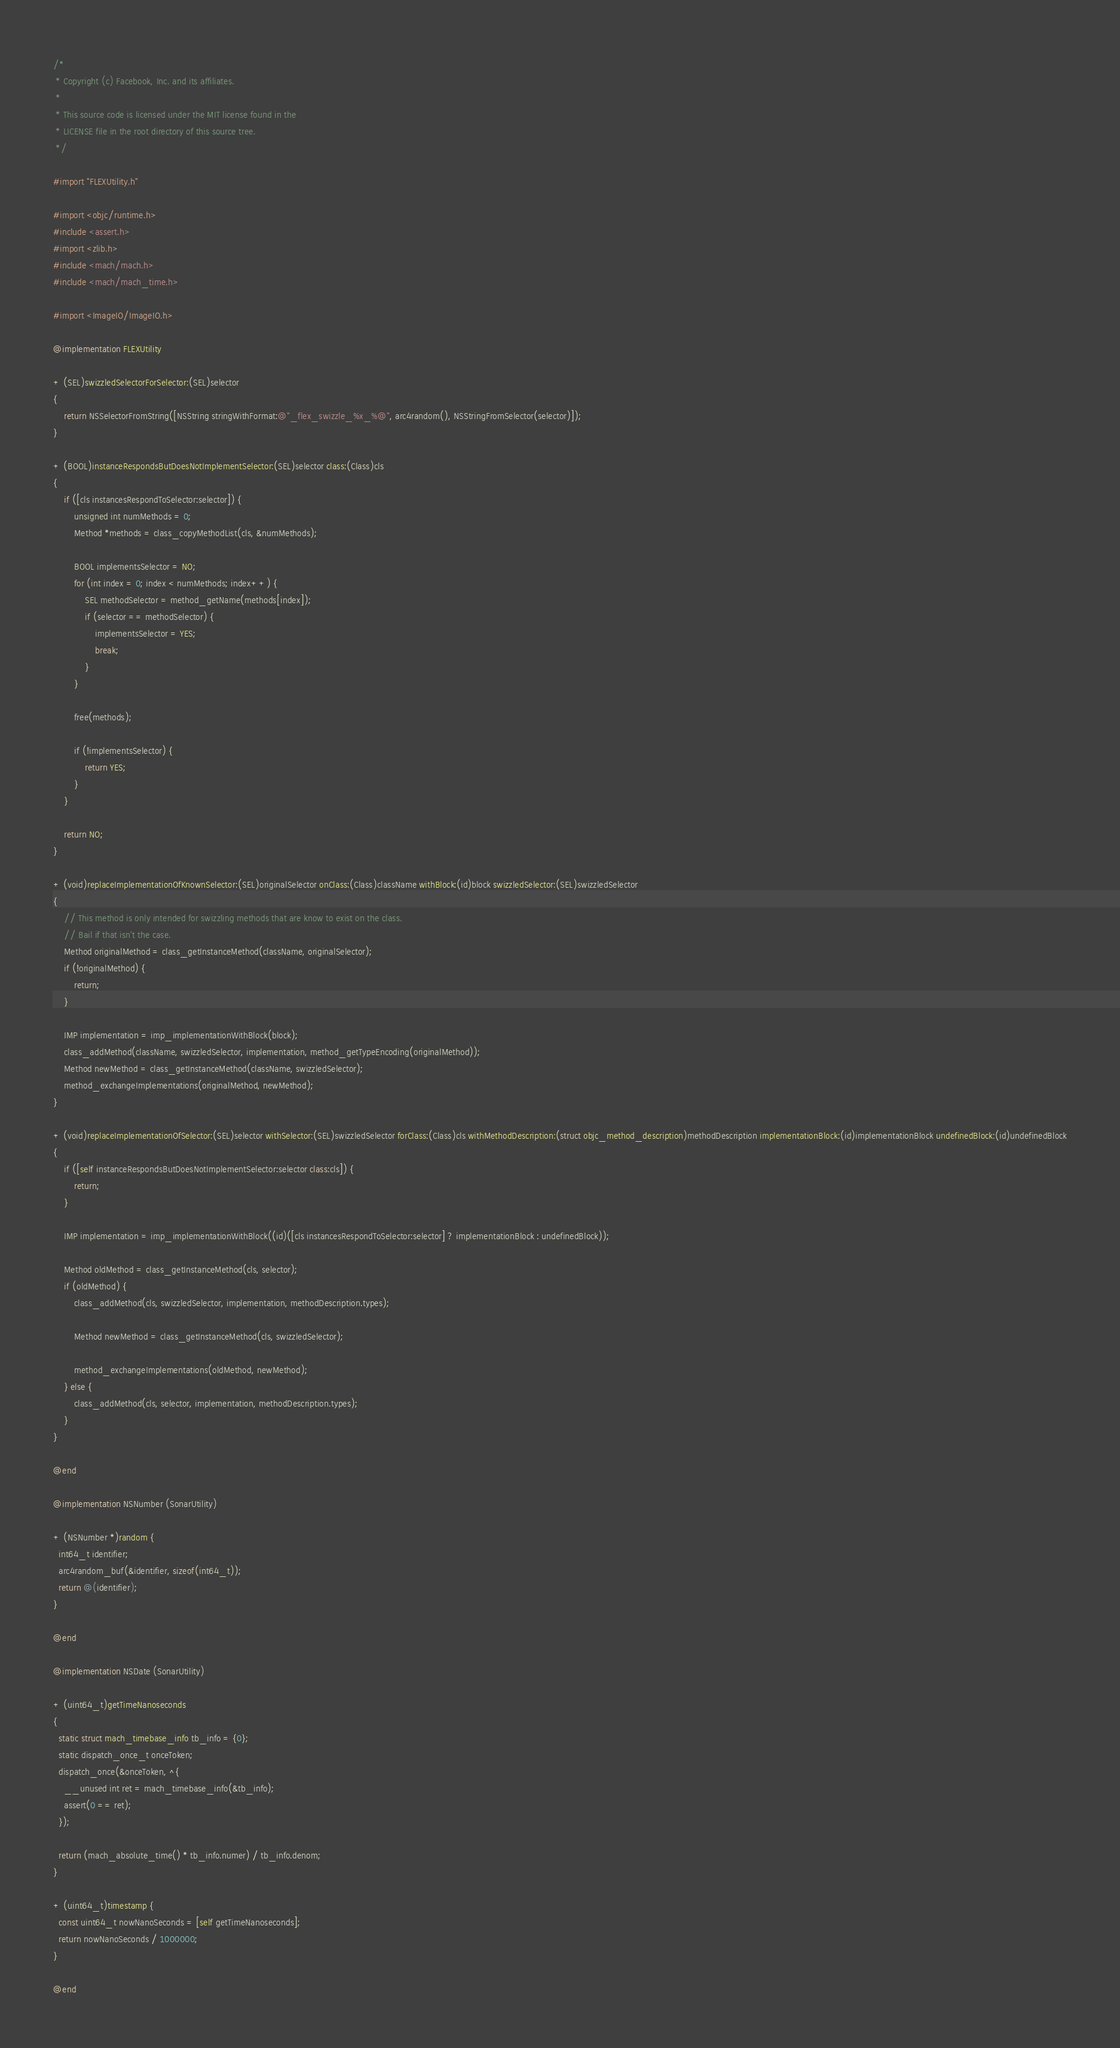Convert code to text. <code><loc_0><loc_0><loc_500><loc_500><_ObjectiveC_>/*
 * Copyright (c) Facebook, Inc. and its affiliates.
 *
 * This source code is licensed under the MIT license found in the
 * LICENSE file in the root directory of this source tree.
 */

#import "FLEXUtility.h"

#import <objc/runtime.h>
#include <assert.h>
#import <zlib.h>
#include <mach/mach.h>
#include <mach/mach_time.h>

#import <ImageIO/ImageIO.h>

@implementation FLEXUtility

+ (SEL)swizzledSelectorForSelector:(SEL)selector
{
    return NSSelectorFromString([NSString stringWithFormat:@"_flex_swizzle_%x_%@", arc4random(), NSStringFromSelector(selector)]);
}

+ (BOOL)instanceRespondsButDoesNotImplementSelector:(SEL)selector class:(Class)cls
{
    if ([cls instancesRespondToSelector:selector]) {
        unsigned int numMethods = 0;
        Method *methods = class_copyMethodList(cls, &numMethods);

        BOOL implementsSelector = NO;
        for (int index = 0; index < numMethods; index++) {
            SEL methodSelector = method_getName(methods[index]);
            if (selector == methodSelector) {
                implementsSelector = YES;
                break;
            }
        }

        free(methods);

        if (!implementsSelector) {
            return YES;
        }
    }

    return NO;
}

+ (void)replaceImplementationOfKnownSelector:(SEL)originalSelector onClass:(Class)className withBlock:(id)block swizzledSelector:(SEL)swizzledSelector
{
    // This method is only intended for swizzling methods that are know to exist on the class.
    // Bail if that isn't the case.
    Method originalMethod = class_getInstanceMethod(className, originalSelector);
    if (!originalMethod) {
        return;
    }

    IMP implementation = imp_implementationWithBlock(block);
    class_addMethod(className, swizzledSelector, implementation, method_getTypeEncoding(originalMethod));
    Method newMethod = class_getInstanceMethod(className, swizzledSelector);
    method_exchangeImplementations(originalMethod, newMethod);
}

+ (void)replaceImplementationOfSelector:(SEL)selector withSelector:(SEL)swizzledSelector forClass:(Class)cls withMethodDescription:(struct objc_method_description)methodDescription implementationBlock:(id)implementationBlock undefinedBlock:(id)undefinedBlock
{
    if ([self instanceRespondsButDoesNotImplementSelector:selector class:cls]) {
        return;
    }

    IMP implementation = imp_implementationWithBlock((id)([cls instancesRespondToSelector:selector] ? implementationBlock : undefinedBlock));

    Method oldMethod = class_getInstanceMethod(cls, selector);
    if (oldMethod) {
        class_addMethod(cls, swizzledSelector, implementation, methodDescription.types);

        Method newMethod = class_getInstanceMethod(cls, swizzledSelector);

        method_exchangeImplementations(oldMethod, newMethod);
    } else {
        class_addMethod(cls, selector, implementation, methodDescription.types);
    }
}

@end

@implementation NSNumber (SonarUtility)

+ (NSNumber *)random {
  int64_t identifier;
  arc4random_buf(&identifier, sizeof(int64_t));
  return @(identifier);
}

@end

@implementation NSDate (SonarUtility)

+ (uint64_t)getTimeNanoseconds
{
  static struct mach_timebase_info tb_info = {0};
  static dispatch_once_t onceToken;
  dispatch_once(&onceToken, ^{
    __unused int ret = mach_timebase_info(&tb_info);
    assert(0 == ret);
  });

  return (mach_absolute_time() * tb_info.numer) / tb_info.denom;
}

+ (uint64_t)timestamp {
  const uint64_t nowNanoSeconds = [self getTimeNanoseconds];
  return nowNanoSeconds / 1000000;
}

@end
</code> 